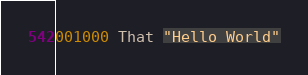Convert code to text. <code><loc_0><loc_0><loc_500><loc_500><_COBOL_>001000 That "Hello World"</code> 